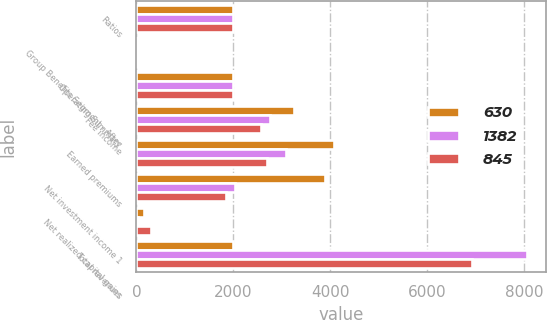Convert chart to OTSL. <chart><loc_0><loc_0><loc_500><loc_500><stacked_bar_chart><ecel><fcel>Ratios<fcel>Group Benefits Segment - After<fcel>Operating Summary<fcel>Fee income<fcel>Earned premiums<fcel>Net investment income 1<fcel>Net realized capital gains<fcel>Total revenues<nl><fcel>630<fcel>2004<fcel>6.3<fcel>2004<fcel>3245<fcel>4072<fcel>3894<fcel>149<fcel>2004<nl><fcel>1382<fcel>2003<fcel>6.4<fcel>2003<fcel>2760<fcel>3086<fcel>2041<fcel>40<fcel>8058<nl><fcel>845<fcel>2002<fcel>5.5<fcel>2002<fcel>2577<fcel>2697<fcel>1849<fcel>308<fcel>6935<nl></chart> 